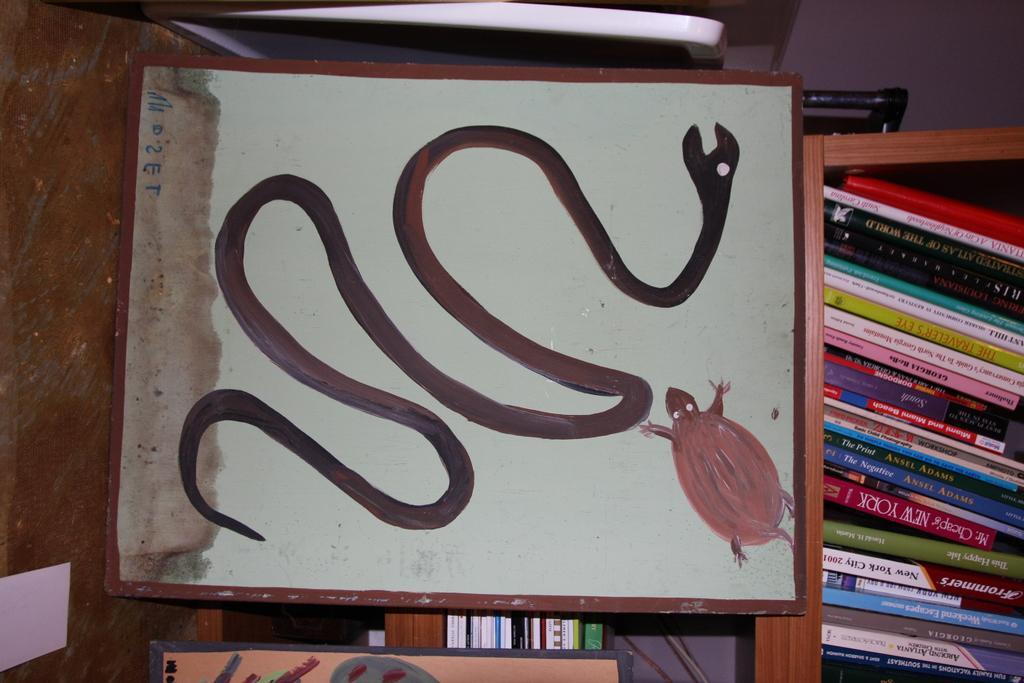Could you give a brief overview of what you see in this image? In this image we can see the drawing of a snake and an insect on the cardboard. Here we can see the books on a wooden shelf on the right side. 